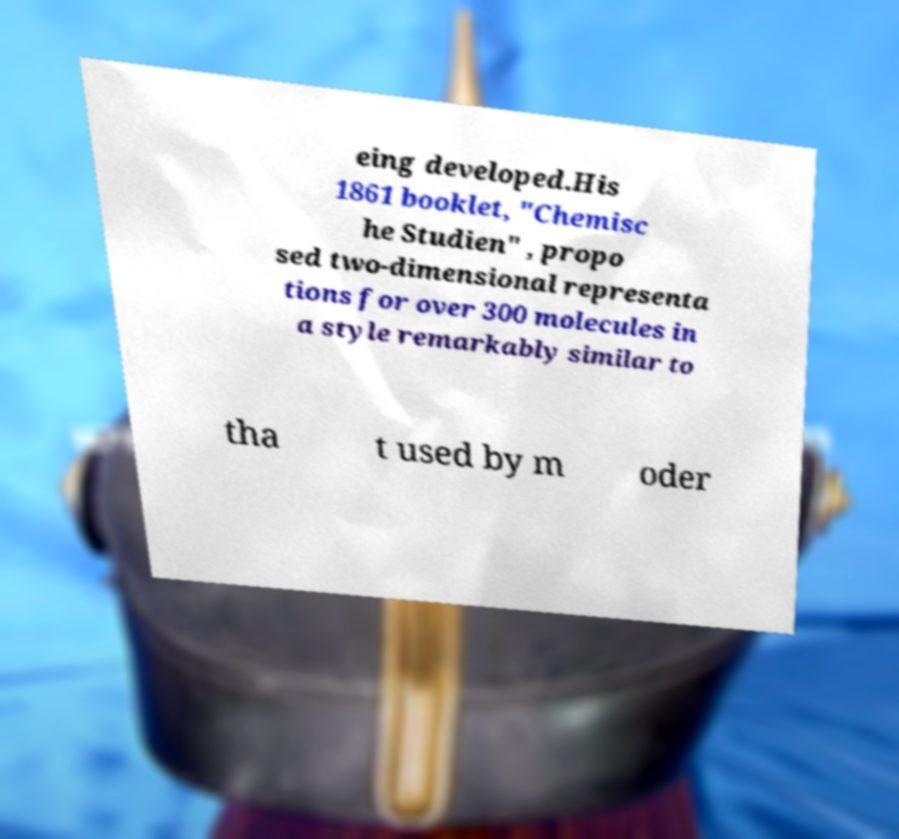Can you read and provide the text displayed in the image?This photo seems to have some interesting text. Can you extract and type it out for me? eing developed.His 1861 booklet, "Chemisc he Studien" , propo sed two-dimensional representa tions for over 300 molecules in a style remarkably similar to tha t used by m oder 